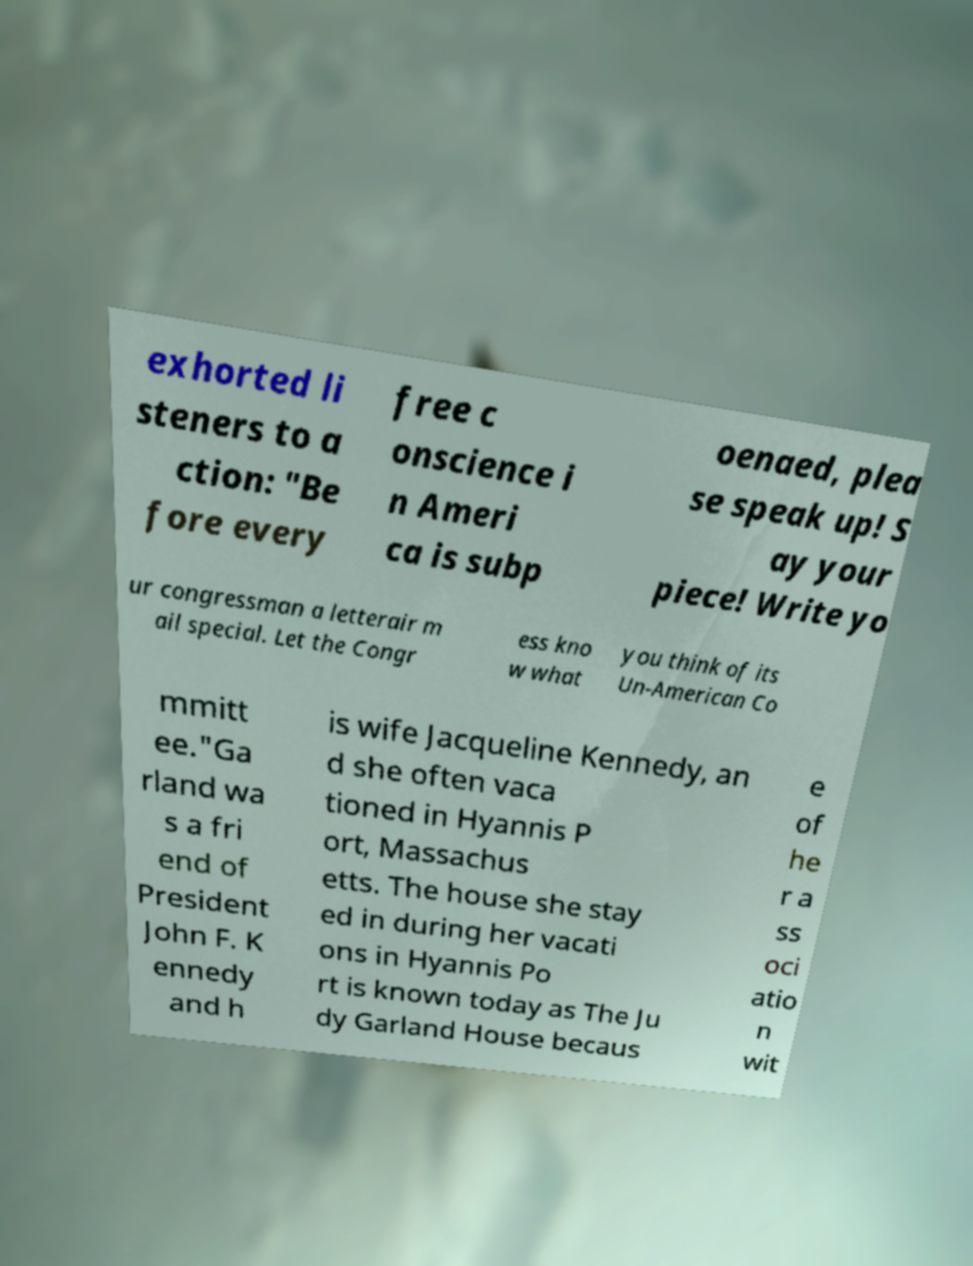Can you accurately transcribe the text from the provided image for me? exhorted li steners to a ction: "Be fore every free c onscience i n Ameri ca is subp oenaed, plea se speak up! S ay your piece! Write yo ur congressman a letterair m ail special. Let the Congr ess kno w what you think of its Un-American Co mmitt ee."Ga rland wa s a fri end of President John F. K ennedy and h is wife Jacqueline Kennedy, an d she often vaca tioned in Hyannis P ort, Massachus etts. The house she stay ed in during her vacati ons in Hyannis Po rt is known today as The Ju dy Garland House becaus e of he r a ss oci atio n wit 